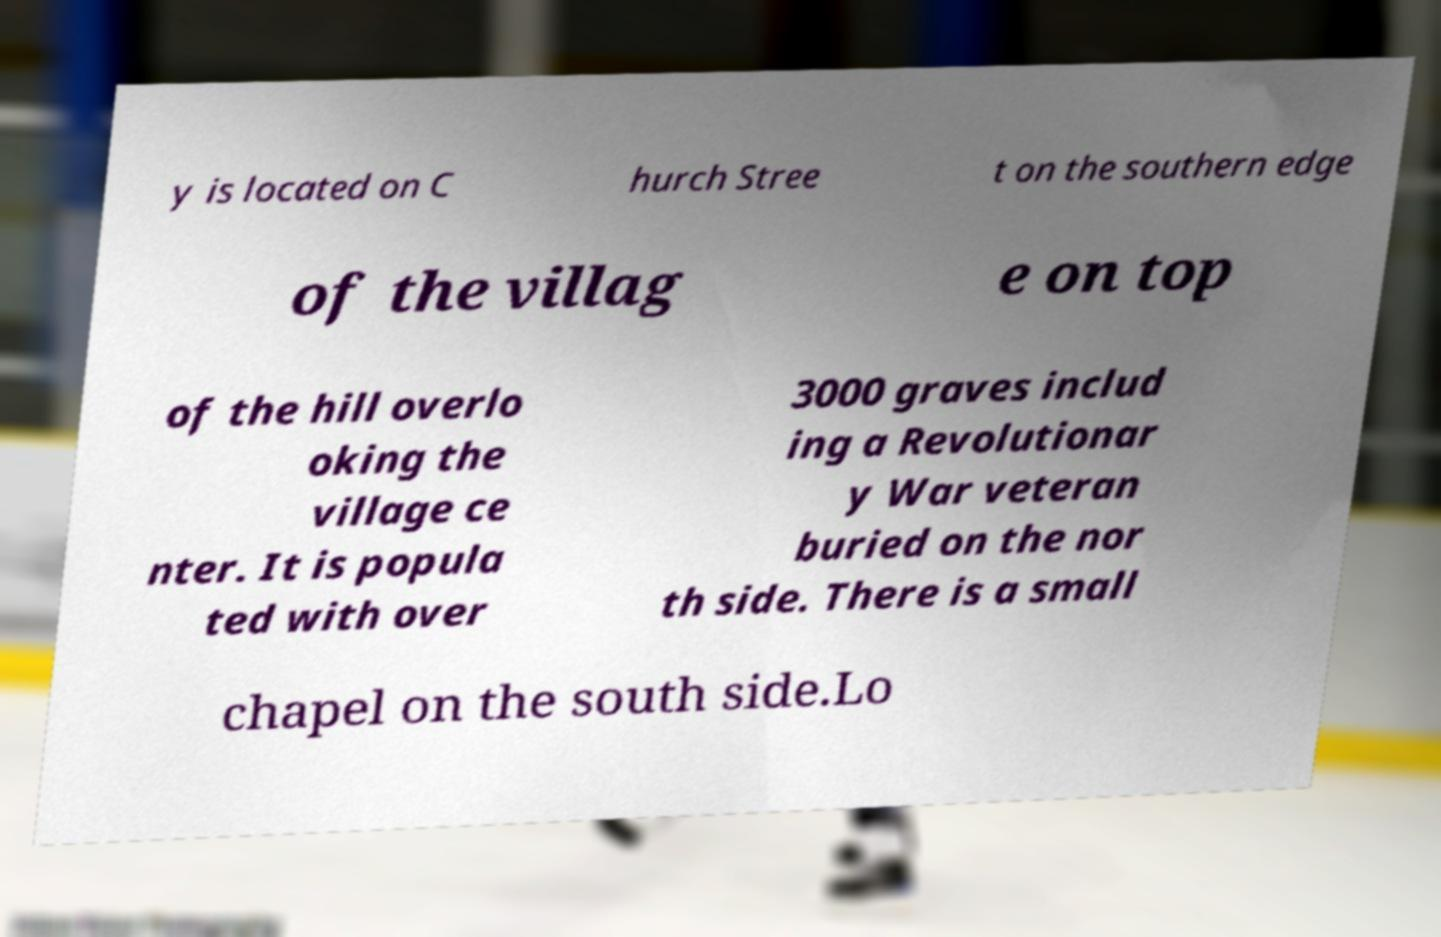Please identify and transcribe the text found in this image. y is located on C hurch Stree t on the southern edge of the villag e on top of the hill overlo oking the village ce nter. It is popula ted with over 3000 graves includ ing a Revolutionar y War veteran buried on the nor th side. There is a small chapel on the south side.Lo 